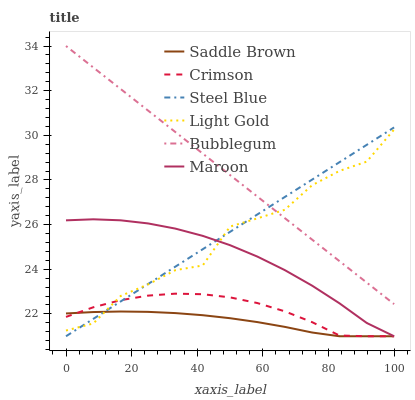Does Saddle Brown have the minimum area under the curve?
Answer yes or no. Yes. Does Bubblegum have the maximum area under the curve?
Answer yes or no. Yes. Does Maroon have the minimum area under the curve?
Answer yes or no. No. Does Maroon have the maximum area under the curve?
Answer yes or no. No. Is Steel Blue the smoothest?
Answer yes or no. Yes. Is Light Gold the roughest?
Answer yes or no. Yes. Is Maroon the smoothest?
Answer yes or no. No. Is Maroon the roughest?
Answer yes or no. No. Does Steel Blue have the lowest value?
Answer yes or no. Yes. Does Bubblegum have the lowest value?
Answer yes or no. No. Does Bubblegum have the highest value?
Answer yes or no. Yes. Does Maroon have the highest value?
Answer yes or no. No. Is Saddle Brown less than Bubblegum?
Answer yes or no. Yes. Is Bubblegum greater than Maroon?
Answer yes or no. Yes. Does Crimson intersect Steel Blue?
Answer yes or no. Yes. Is Crimson less than Steel Blue?
Answer yes or no. No. Is Crimson greater than Steel Blue?
Answer yes or no. No. Does Saddle Brown intersect Bubblegum?
Answer yes or no. No. 